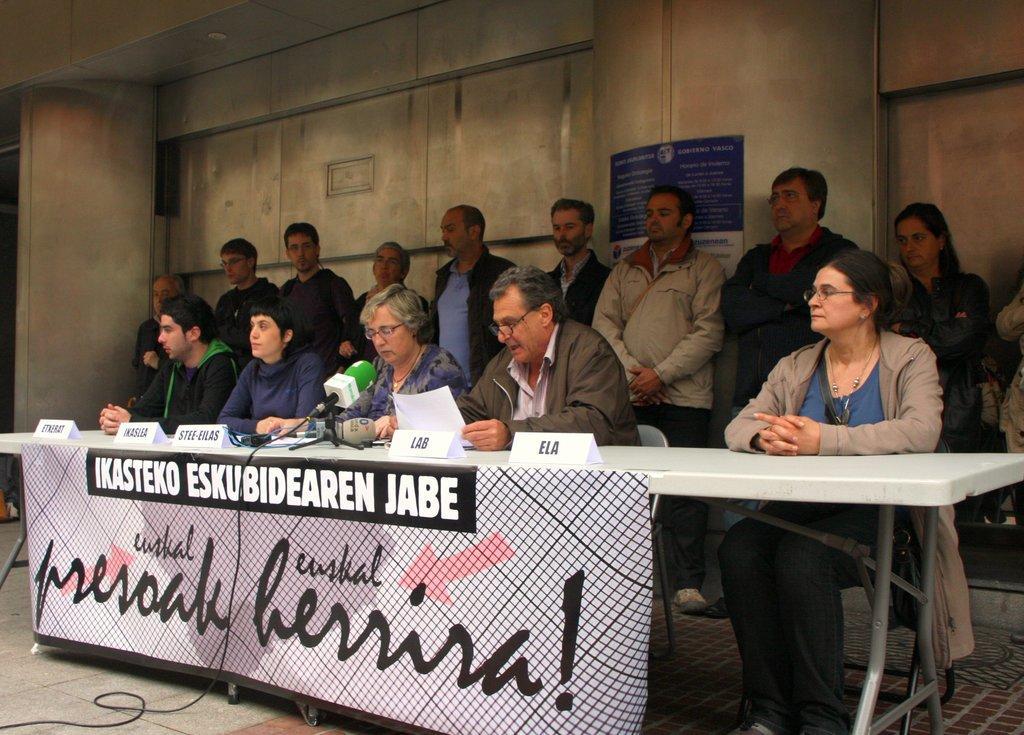Can you describe this image briefly? In this image, There is a table which is in white color and there are some microphones on the table, There is a poster on the table and there are some people sitting on the chairs, In the background there are some people standing and there is a wall in yellow color. 